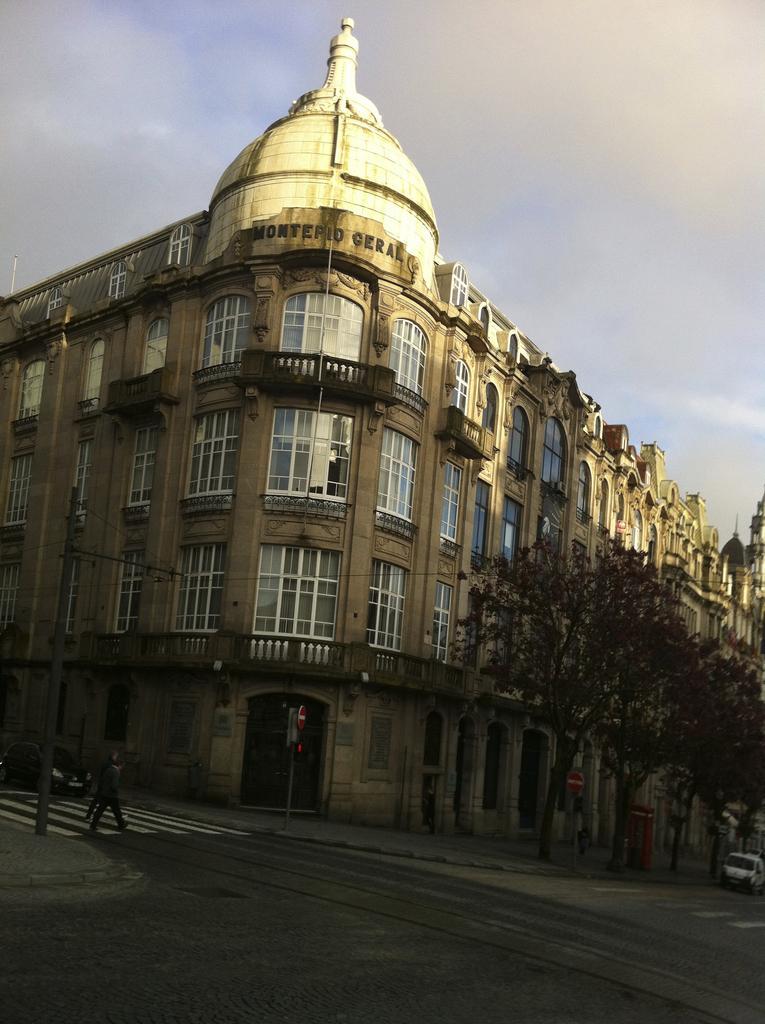Describe this image in one or two sentences. In this image in the background there is a building and on the building there is some text written on it and on the right side there are trees, there is a car and on the left side there is a pole and there are persons walking and there is a vehicle and the sky is cloudy. 